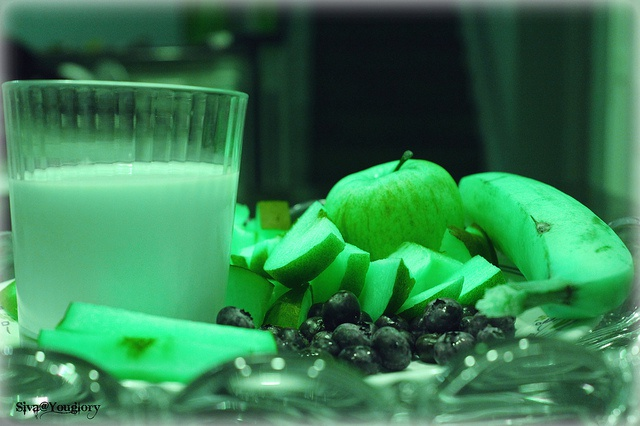Describe the objects in this image and their specific colors. I can see cup in darkgray, lightgreen, and darkgreen tones, apple in darkgray, green, darkgreen, and lightgreen tones, banana in darkgray, lightgreen, darkgreen, and green tones, apple in darkgray, aquamarine, lightgreen, and green tones, and cup in black, darkgreen, lightgreen, and darkgray tones in this image. 